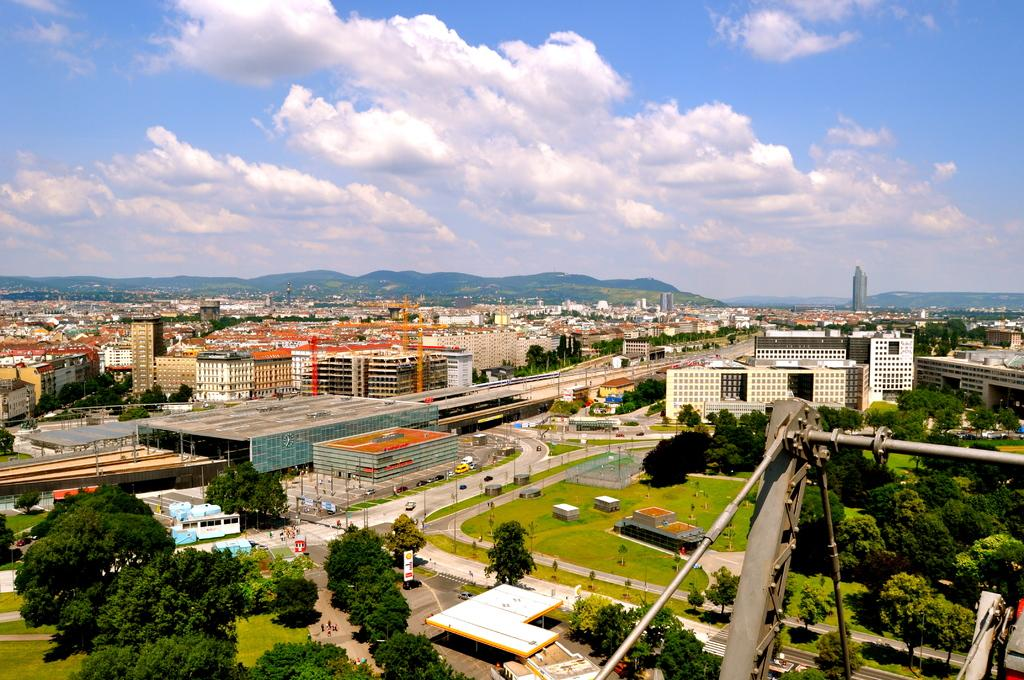What type of vegetation can be seen in the image? There are green color trees in the image. What else can be seen in the image besides trees? There are roads and buildings in the image. What is the color of the sky in the image? The sky is blue in color. Are there any clouds visible in the sky? Yes, there are white color clouds in the sky. What type of party is being held in the image? There is no party present in the image; it features green trees, roads, buildings, a blue sky, and white clouds. What is the tendency of the branches in the image? There is no mention of branches in the image; it only features trees, roads, buildings, a blue sky, and white clouds. 